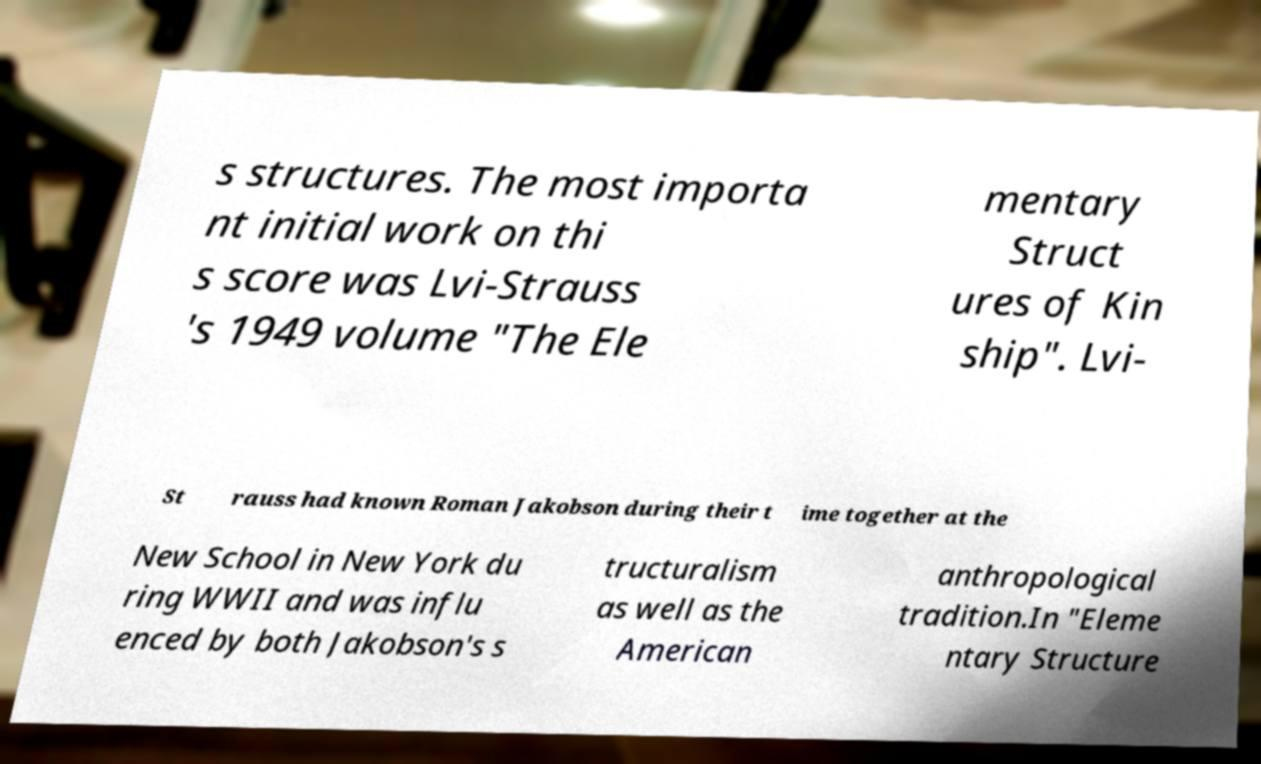What messages or text are displayed in this image? I need them in a readable, typed format. s structures. The most importa nt initial work on thi s score was Lvi-Strauss 's 1949 volume "The Ele mentary Struct ures of Kin ship". Lvi- St rauss had known Roman Jakobson during their t ime together at the New School in New York du ring WWII and was influ enced by both Jakobson's s tructuralism as well as the American anthropological tradition.In "Eleme ntary Structure 